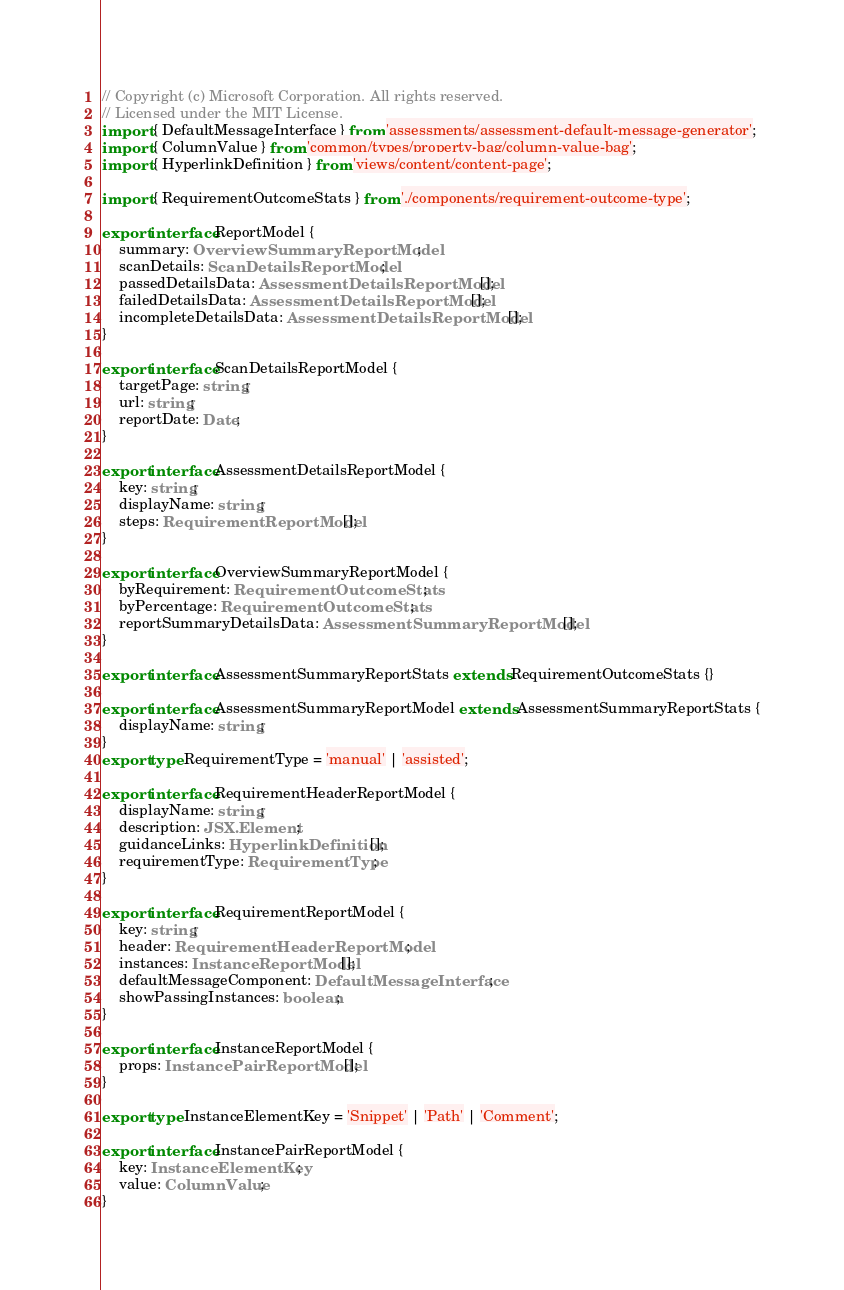Convert code to text. <code><loc_0><loc_0><loc_500><loc_500><_TypeScript_>// Copyright (c) Microsoft Corporation. All rights reserved.
// Licensed under the MIT License.
import { DefaultMessageInterface } from 'assessments/assessment-default-message-generator';
import { ColumnValue } from 'common/types/property-bag/column-value-bag';
import { HyperlinkDefinition } from 'views/content/content-page';

import { RequirementOutcomeStats } from './components/requirement-outcome-type';

export interface ReportModel {
    summary: OverviewSummaryReportModel;
    scanDetails: ScanDetailsReportModel;
    passedDetailsData: AssessmentDetailsReportModel[];
    failedDetailsData: AssessmentDetailsReportModel[];
    incompleteDetailsData: AssessmentDetailsReportModel[];
}

export interface ScanDetailsReportModel {
    targetPage: string;
    url: string;
    reportDate: Date;
}

export interface AssessmentDetailsReportModel {
    key: string;
    displayName: string;
    steps: RequirementReportModel[];
}

export interface OverviewSummaryReportModel {
    byRequirement: RequirementOutcomeStats;
    byPercentage: RequirementOutcomeStats;
    reportSummaryDetailsData: AssessmentSummaryReportModel[];
}

export interface AssessmentSummaryReportStats extends RequirementOutcomeStats {}

export interface AssessmentSummaryReportModel extends AssessmentSummaryReportStats {
    displayName: string;
}
export type RequirementType = 'manual' | 'assisted';

export interface RequirementHeaderReportModel {
    displayName: string;
    description: JSX.Element;
    guidanceLinks: HyperlinkDefinition[];
    requirementType: RequirementType;
}

export interface RequirementReportModel {
    key: string;
    header: RequirementHeaderReportModel;
    instances: InstanceReportModel[];
    defaultMessageComponent: DefaultMessageInterface;
    showPassingInstances: boolean;
}

export interface InstanceReportModel {
    props: InstancePairReportModel[];
}

export type InstanceElementKey = 'Snippet' | 'Path' | 'Comment';

export interface InstancePairReportModel {
    key: InstanceElementKey;
    value: ColumnValue;
}
</code> 